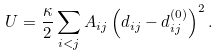Convert formula to latex. <formula><loc_0><loc_0><loc_500><loc_500>U = \frac { \kappa } { 2 } \sum _ { i < j } A _ { i j } \left ( d _ { i j } - d _ { i j } ^ { ( 0 ) } \right ) ^ { 2 } .</formula> 